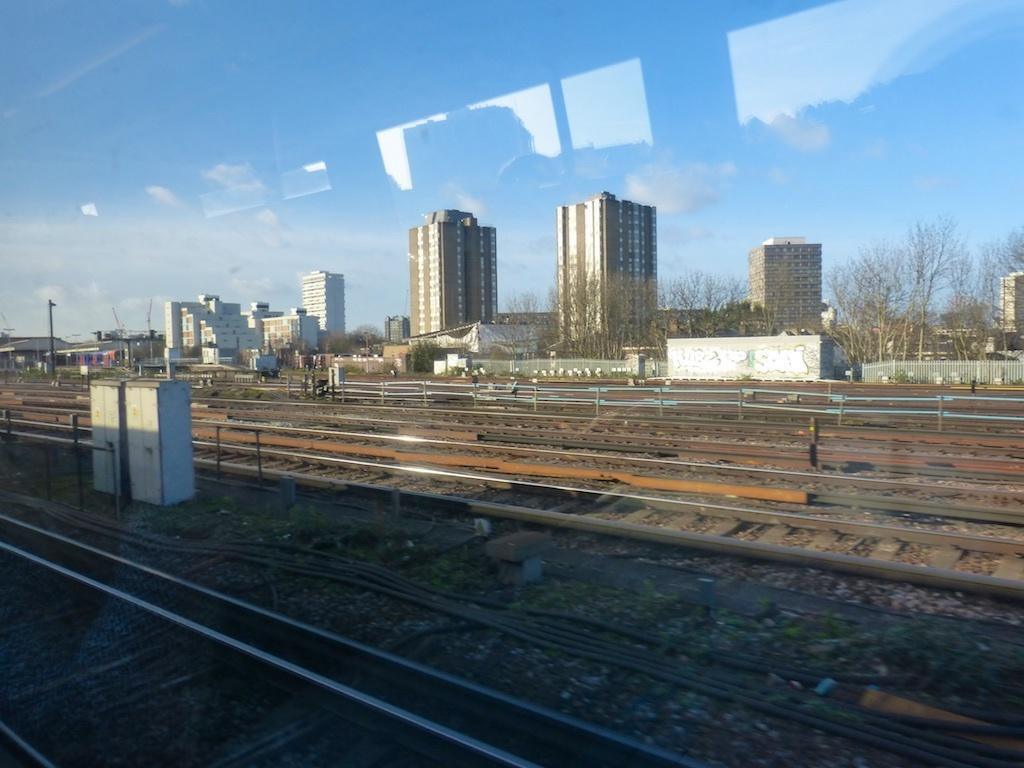What type of transportation infrastructure is visible in the image? There are railway tracks in the image. What else can be seen in the image besides the railway tracks? There are pipes, cabins, buildings, trees, and the sky visible in the image. Can you describe the cabins in the image? The cabins are small structures that might be used for accommodation or storage. What is visible in the background of the image? There are buildings, trees, and the sky visible in the background of the image. Can you see any ghosts interacting with the railway tracks in the image? There are no ghosts present in the image; it only features railway tracks, pipes, cabins, buildings, trees, and the sky. 